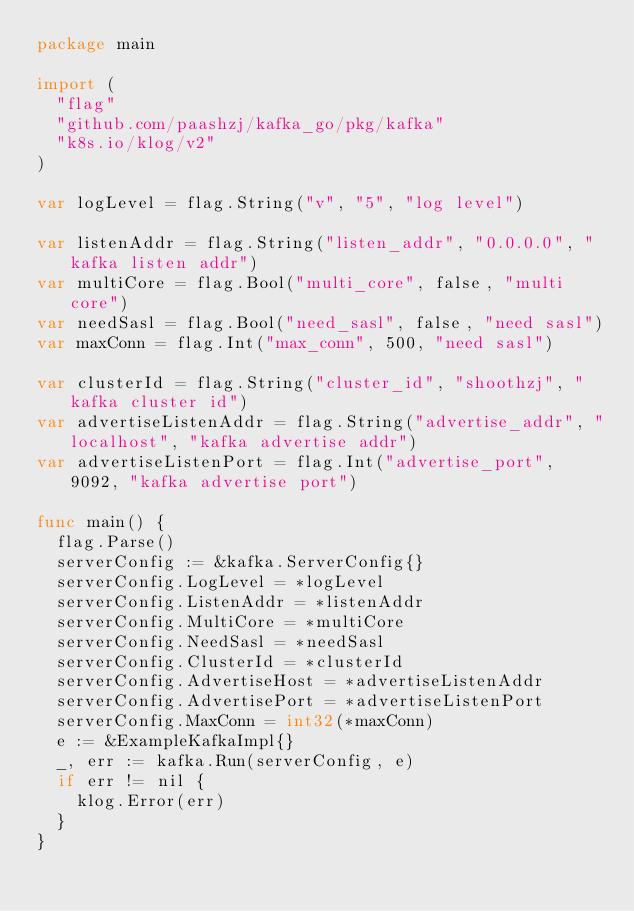<code> <loc_0><loc_0><loc_500><loc_500><_Go_>package main

import (
	"flag"
	"github.com/paashzj/kafka_go/pkg/kafka"
	"k8s.io/klog/v2"
)

var logLevel = flag.String("v", "5", "log level")

var listenAddr = flag.String("listen_addr", "0.0.0.0", "kafka listen addr")
var multiCore = flag.Bool("multi_core", false, "multi core")
var needSasl = flag.Bool("need_sasl", false, "need sasl")
var maxConn = flag.Int("max_conn", 500, "need sasl")

var clusterId = flag.String("cluster_id", "shoothzj", "kafka cluster id")
var advertiseListenAddr = flag.String("advertise_addr", "localhost", "kafka advertise addr")
var advertiseListenPort = flag.Int("advertise_port", 9092, "kafka advertise port")

func main() {
	flag.Parse()
	serverConfig := &kafka.ServerConfig{}
	serverConfig.LogLevel = *logLevel
	serverConfig.ListenAddr = *listenAddr
	serverConfig.MultiCore = *multiCore
	serverConfig.NeedSasl = *needSasl
	serverConfig.ClusterId = *clusterId
	serverConfig.AdvertiseHost = *advertiseListenAddr
	serverConfig.AdvertisePort = *advertiseListenPort
	serverConfig.MaxConn = int32(*maxConn)
	e := &ExampleKafkaImpl{}
	_, err := kafka.Run(serverConfig, e)
	if err != nil {
		klog.Error(err)
	}
}
</code> 